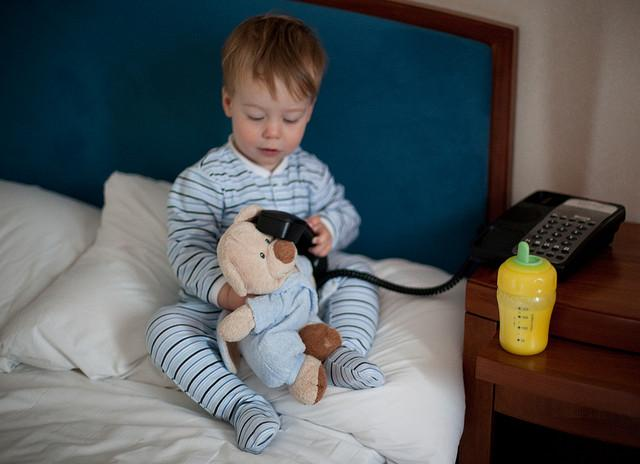What does the child imagine his toy bear does now?

Choices:
A) eat honey
B) phone call
C) make house
D) sing song phone call 